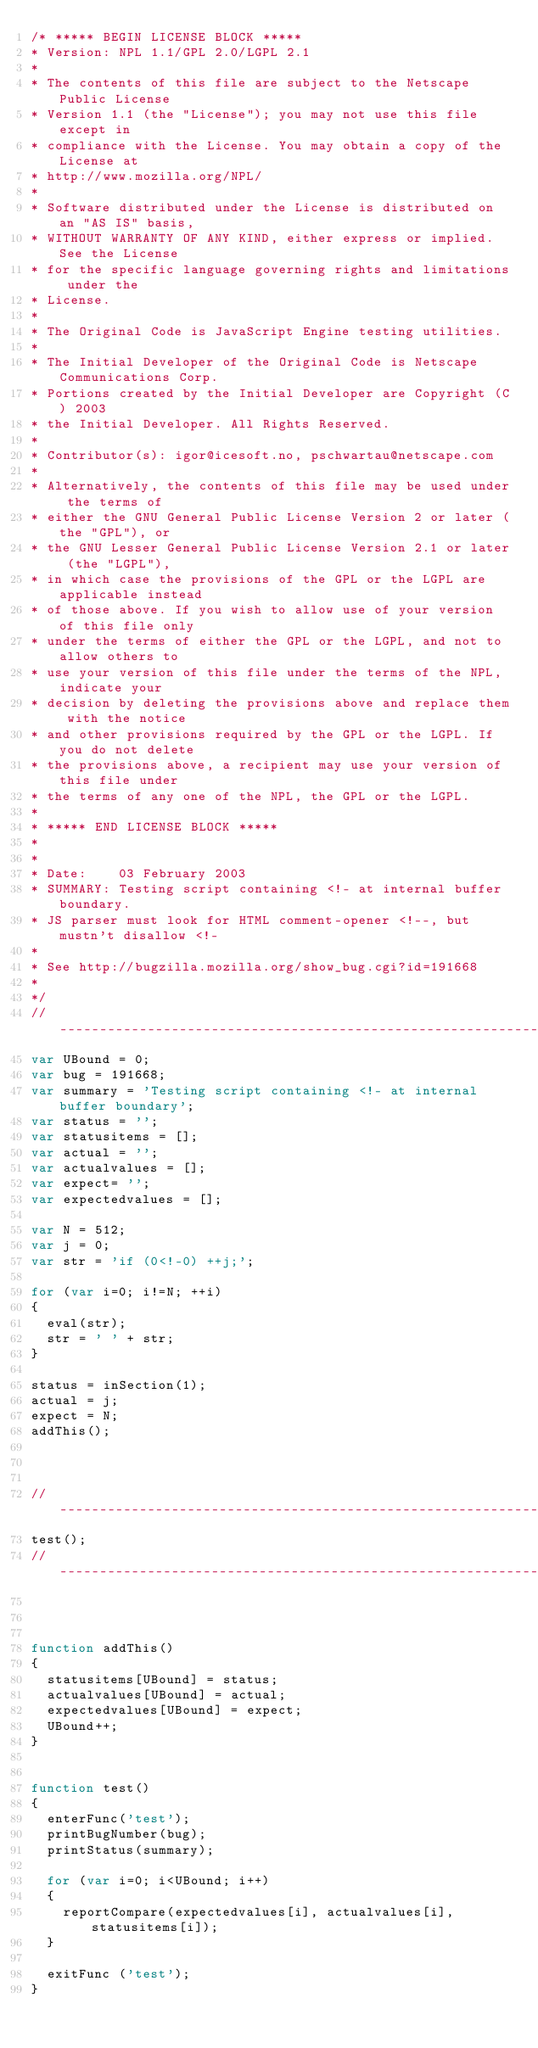Convert code to text. <code><loc_0><loc_0><loc_500><loc_500><_JavaScript_>/* ***** BEGIN LICENSE BLOCK *****
* Version: NPL 1.1/GPL 2.0/LGPL 2.1
*
* The contents of this file are subject to the Netscape Public License
* Version 1.1 (the "License"); you may not use this file except in
* compliance with the License. You may obtain a copy of the License at
* http://www.mozilla.org/NPL/
*
* Software distributed under the License is distributed on an "AS IS" basis,
* WITHOUT WARRANTY OF ANY KIND, either express or implied. See the License
* for the specific language governing rights and limitations under the
* License.
*
* The Original Code is JavaScript Engine testing utilities.
*
* The Initial Developer of the Original Code is Netscape Communications Corp.
* Portions created by the Initial Developer are Copyright (C) 2003
* the Initial Developer. All Rights Reserved.
*
* Contributor(s): igor@icesoft.no, pschwartau@netscape.com
*
* Alternatively, the contents of this file may be used under the terms of
* either the GNU General Public License Version 2 or later (the "GPL"), or
* the GNU Lesser General Public License Version 2.1 or later (the "LGPL"),
* in which case the provisions of the GPL or the LGPL are applicable instead
* of those above. If you wish to allow use of your version of this file only
* under the terms of either the GPL or the LGPL, and not to allow others to
* use your version of this file under the terms of the NPL, indicate your
* decision by deleting the provisions above and replace them with the notice
* and other provisions required by the GPL or the LGPL. If you do not delete
* the provisions above, a recipient may use your version of this file under
* the terms of any one of the NPL, the GPL or the LGPL.
*
* ***** END LICENSE BLOCK *****
*
*
* Date:    03 February 2003
* SUMMARY: Testing script containing <!- at internal buffer boundary.
* JS parser must look for HTML comment-opener <!--, but mustn't disallow <!-
*
* See http://bugzilla.mozilla.org/show_bug.cgi?id=191668
*
*/
//-----------------------------------------------------------------------------
var UBound = 0;
var bug = 191668;
var summary = 'Testing script containing <!- at internal buffer boundary';
var status = '';
var statusitems = [];
var actual = '';
var actualvalues = [];
var expect= '';
var expectedvalues = [];

var N = 512;
var j = 0;
var str = 'if (0<!-0) ++j;';

for (var i=0; i!=N; ++i)
{
  eval(str);
  str = ' ' + str;
}

status = inSection(1);
actual = j;
expect = N;
addThis();



//-----------------------------------------------------------------------------
test();
//-----------------------------------------------------------------------------



function addThis()
{
  statusitems[UBound] = status;
  actualvalues[UBound] = actual;
  expectedvalues[UBound] = expect;
  UBound++;
}


function test()
{
  enterFunc('test');
  printBugNumber(bug);
  printStatus(summary);

  for (var i=0; i<UBound; i++)
  {
    reportCompare(expectedvalues[i], actualvalues[i], statusitems[i]);
  }

  exitFunc ('test');
}
</code> 